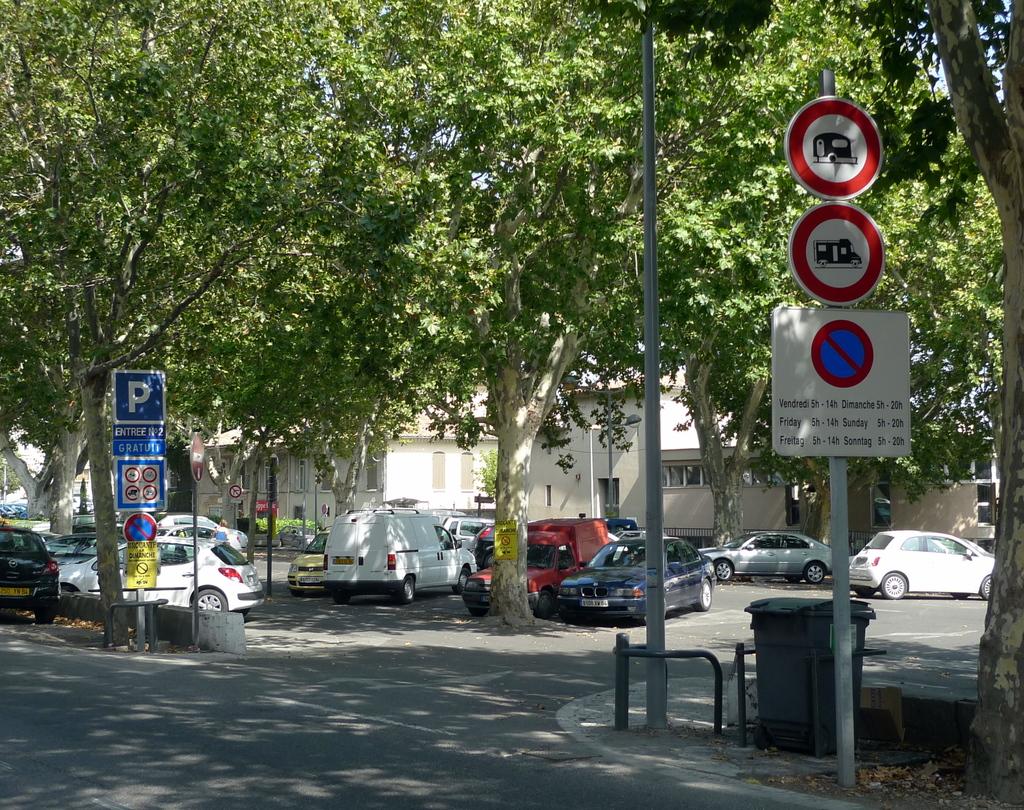What does the red and blue sign indicate?
Your response must be concise. No parking. What letter is in large blue square?
Ensure brevity in your answer.  P. 